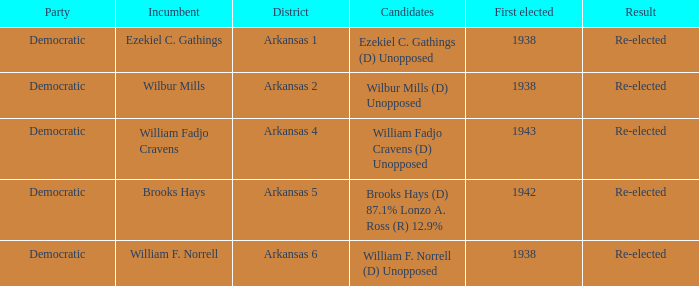To which party did incumbent brooks hays have membership? Democratic. 